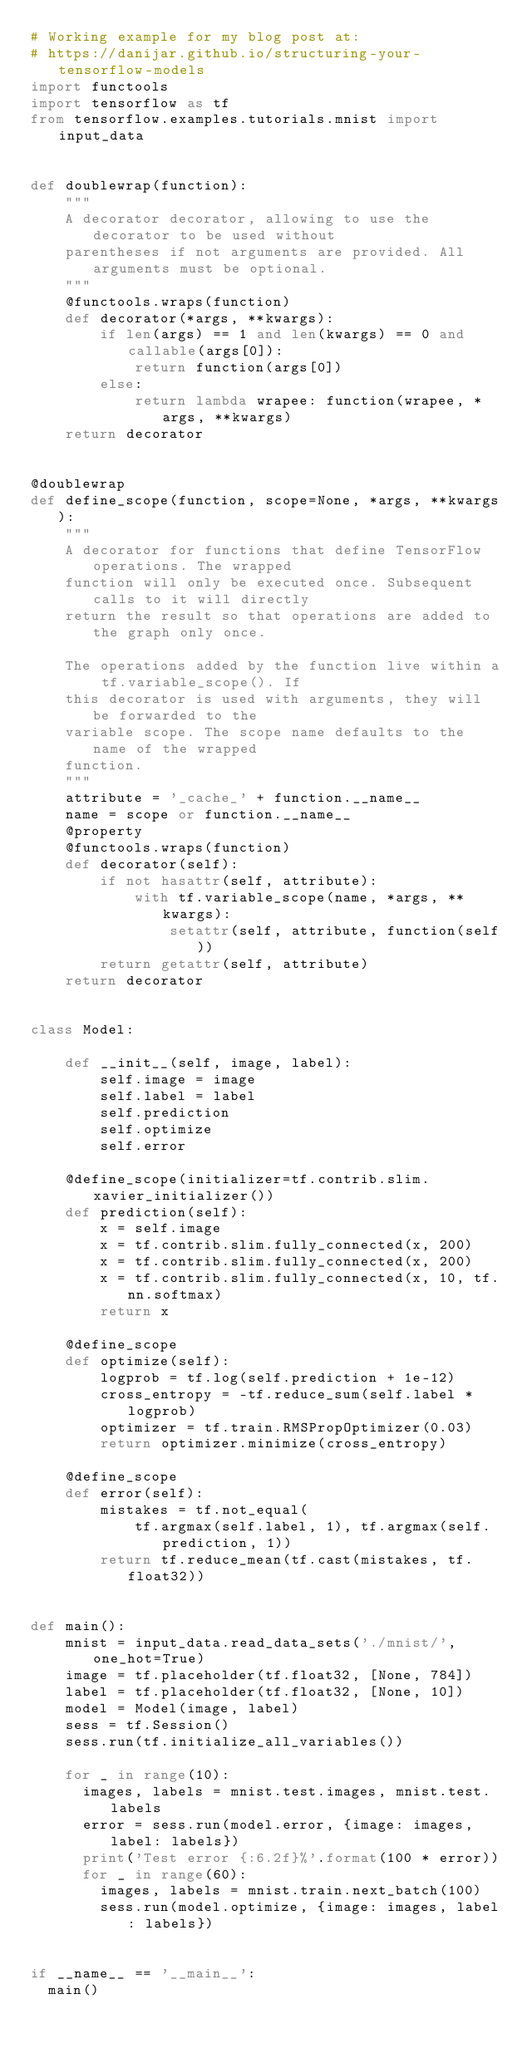<code> <loc_0><loc_0><loc_500><loc_500><_Python_># Working example for my blog post at:
# https://danijar.github.io/structuring-your-tensorflow-models
import functools
import tensorflow as tf
from tensorflow.examples.tutorials.mnist import input_data


def doublewrap(function):
    """
    A decorator decorator, allowing to use the decorator to be used without
    parentheses if not arguments are provided. All arguments must be optional.
    """
    @functools.wraps(function)
    def decorator(*args, **kwargs):
        if len(args) == 1 and len(kwargs) == 0 and callable(args[0]):
            return function(args[0])
        else:
            return lambda wrapee: function(wrapee, *args, **kwargs)
    return decorator


@doublewrap
def define_scope(function, scope=None, *args, **kwargs):
    """
    A decorator for functions that define TensorFlow operations. The wrapped
    function will only be executed once. Subsequent calls to it will directly
    return the result so that operations are added to the graph only once.

    The operations added by the function live within a tf.variable_scope(). If
    this decorator is used with arguments, they will be forwarded to the
    variable scope. The scope name defaults to the name of the wrapped
    function.
    """
    attribute = '_cache_' + function.__name__
    name = scope or function.__name__
    @property
    @functools.wraps(function)
    def decorator(self):
        if not hasattr(self, attribute):
            with tf.variable_scope(name, *args, **kwargs):
                setattr(self, attribute, function(self))
        return getattr(self, attribute)
    return decorator


class Model:

    def __init__(self, image, label):
        self.image = image
        self.label = label
        self.prediction
        self.optimize
        self.error

    @define_scope(initializer=tf.contrib.slim.xavier_initializer())
    def prediction(self):
        x = self.image
        x = tf.contrib.slim.fully_connected(x, 200)
        x = tf.contrib.slim.fully_connected(x, 200)
        x = tf.contrib.slim.fully_connected(x, 10, tf.nn.softmax)
        return x

    @define_scope
    def optimize(self):
        logprob = tf.log(self.prediction + 1e-12)
        cross_entropy = -tf.reduce_sum(self.label * logprob)
        optimizer = tf.train.RMSPropOptimizer(0.03)
        return optimizer.minimize(cross_entropy)

    @define_scope
    def error(self):
        mistakes = tf.not_equal(
            tf.argmax(self.label, 1), tf.argmax(self.prediction, 1))
        return tf.reduce_mean(tf.cast(mistakes, tf.float32))


def main():
    mnist = input_data.read_data_sets('./mnist/', one_hot=True)
    image = tf.placeholder(tf.float32, [None, 784])
    label = tf.placeholder(tf.float32, [None, 10])
    model = Model(image, label)
    sess = tf.Session()
    sess.run(tf.initialize_all_variables())

    for _ in range(10):
      images, labels = mnist.test.images, mnist.test.labels
      error = sess.run(model.error, {image: images, label: labels})
      print('Test error {:6.2f}%'.format(100 * error))
      for _ in range(60):
        images, labels = mnist.train.next_batch(100)
        sess.run(model.optimize, {image: images, label: labels})


if __name__ == '__main__':
  main()</code> 